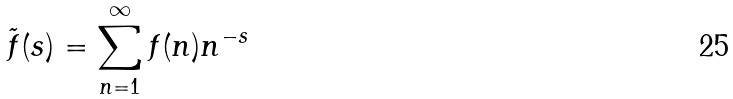<formula> <loc_0><loc_0><loc_500><loc_500>\tilde { f } ( s ) = \sum _ { n = 1 } ^ { \infty } f ( n ) n ^ { - s }</formula> 